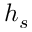Convert formula to latex. <formula><loc_0><loc_0><loc_500><loc_500>h _ { s }</formula> 